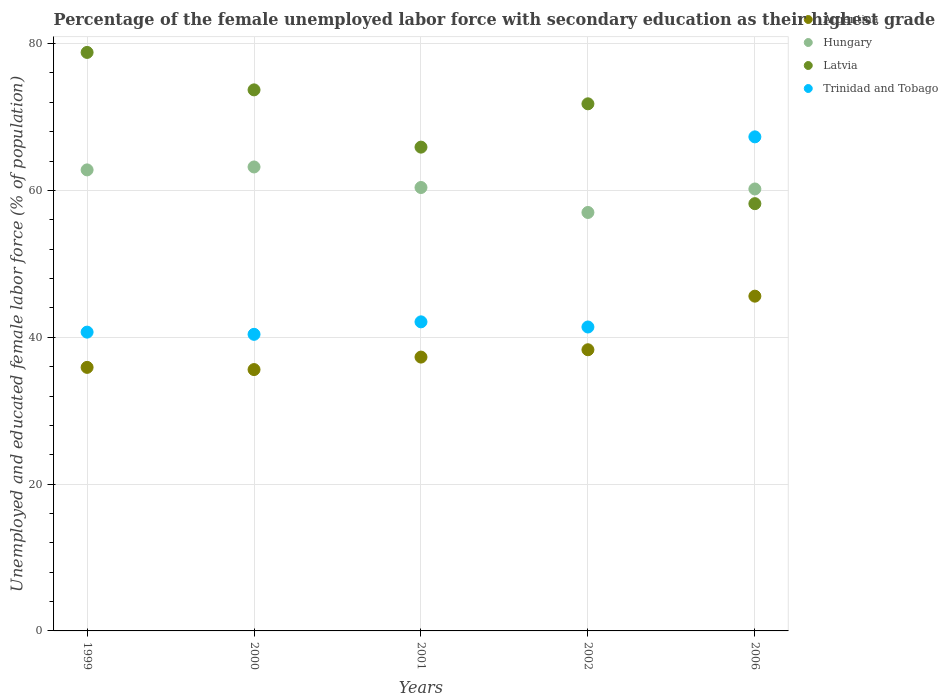How many different coloured dotlines are there?
Give a very brief answer. 4. Is the number of dotlines equal to the number of legend labels?
Offer a very short reply. Yes. What is the percentage of the unemployed female labor force with secondary education in Hungary in 2001?
Make the answer very short. 60.4. Across all years, what is the maximum percentage of the unemployed female labor force with secondary education in Hungary?
Your answer should be very brief. 63.2. Across all years, what is the minimum percentage of the unemployed female labor force with secondary education in Argentina?
Offer a very short reply. 35.6. In which year was the percentage of the unemployed female labor force with secondary education in Hungary maximum?
Provide a short and direct response. 2000. What is the total percentage of the unemployed female labor force with secondary education in Hungary in the graph?
Make the answer very short. 303.6. What is the difference between the percentage of the unemployed female labor force with secondary education in Argentina in 2000 and that in 2002?
Provide a succinct answer. -2.7. What is the difference between the percentage of the unemployed female labor force with secondary education in Latvia in 2006 and the percentage of the unemployed female labor force with secondary education in Trinidad and Tobago in 2001?
Ensure brevity in your answer.  16.1. What is the average percentage of the unemployed female labor force with secondary education in Trinidad and Tobago per year?
Offer a very short reply. 46.38. In the year 2000, what is the difference between the percentage of the unemployed female labor force with secondary education in Trinidad and Tobago and percentage of the unemployed female labor force with secondary education in Hungary?
Offer a very short reply. -22.8. What is the ratio of the percentage of the unemployed female labor force with secondary education in Hungary in 2000 to that in 2002?
Provide a short and direct response. 1.11. Is the percentage of the unemployed female labor force with secondary education in Trinidad and Tobago in 1999 less than that in 2002?
Offer a terse response. Yes. Is the difference between the percentage of the unemployed female labor force with secondary education in Trinidad and Tobago in 1999 and 2006 greater than the difference between the percentage of the unemployed female labor force with secondary education in Hungary in 1999 and 2006?
Make the answer very short. No. What is the difference between the highest and the second highest percentage of the unemployed female labor force with secondary education in Hungary?
Make the answer very short. 0.4. What is the difference between the highest and the lowest percentage of the unemployed female labor force with secondary education in Hungary?
Your answer should be compact. 6.2. Is it the case that in every year, the sum of the percentage of the unemployed female labor force with secondary education in Hungary and percentage of the unemployed female labor force with secondary education in Argentina  is greater than the sum of percentage of the unemployed female labor force with secondary education in Trinidad and Tobago and percentage of the unemployed female labor force with secondary education in Latvia?
Offer a terse response. No. Does the percentage of the unemployed female labor force with secondary education in Hungary monotonically increase over the years?
Make the answer very short. No. How many dotlines are there?
Make the answer very short. 4. What is the difference between two consecutive major ticks on the Y-axis?
Ensure brevity in your answer.  20. Are the values on the major ticks of Y-axis written in scientific E-notation?
Keep it short and to the point. No. Does the graph contain grids?
Ensure brevity in your answer.  Yes. Where does the legend appear in the graph?
Provide a short and direct response. Top right. What is the title of the graph?
Provide a short and direct response. Percentage of the female unemployed labor force with secondary education as their highest grade. What is the label or title of the Y-axis?
Your answer should be compact. Unemployed and educated female labor force (% of population). What is the Unemployed and educated female labor force (% of population) in Argentina in 1999?
Make the answer very short. 35.9. What is the Unemployed and educated female labor force (% of population) in Hungary in 1999?
Provide a succinct answer. 62.8. What is the Unemployed and educated female labor force (% of population) in Latvia in 1999?
Offer a terse response. 78.8. What is the Unemployed and educated female labor force (% of population) of Trinidad and Tobago in 1999?
Ensure brevity in your answer.  40.7. What is the Unemployed and educated female labor force (% of population) of Argentina in 2000?
Your answer should be very brief. 35.6. What is the Unemployed and educated female labor force (% of population) of Hungary in 2000?
Your response must be concise. 63.2. What is the Unemployed and educated female labor force (% of population) in Latvia in 2000?
Offer a very short reply. 73.7. What is the Unemployed and educated female labor force (% of population) of Trinidad and Tobago in 2000?
Provide a succinct answer. 40.4. What is the Unemployed and educated female labor force (% of population) in Argentina in 2001?
Offer a very short reply. 37.3. What is the Unemployed and educated female labor force (% of population) in Hungary in 2001?
Your answer should be compact. 60.4. What is the Unemployed and educated female labor force (% of population) of Latvia in 2001?
Keep it short and to the point. 65.9. What is the Unemployed and educated female labor force (% of population) in Trinidad and Tobago in 2001?
Make the answer very short. 42.1. What is the Unemployed and educated female labor force (% of population) of Argentina in 2002?
Ensure brevity in your answer.  38.3. What is the Unemployed and educated female labor force (% of population) in Latvia in 2002?
Give a very brief answer. 71.8. What is the Unemployed and educated female labor force (% of population) of Trinidad and Tobago in 2002?
Offer a terse response. 41.4. What is the Unemployed and educated female labor force (% of population) in Argentina in 2006?
Give a very brief answer. 45.6. What is the Unemployed and educated female labor force (% of population) in Hungary in 2006?
Keep it short and to the point. 60.2. What is the Unemployed and educated female labor force (% of population) in Latvia in 2006?
Your response must be concise. 58.2. What is the Unemployed and educated female labor force (% of population) of Trinidad and Tobago in 2006?
Keep it short and to the point. 67.3. Across all years, what is the maximum Unemployed and educated female labor force (% of population) in Argentina?
Your response must be concise. 45.6. Across all years, what is the maximum Unemployed and educated female labor force (% of population) in Hungary?
Offer a very short reply. 63.2. Across all years, what is the maximum Unemployed and educated female labor force (% of population) of Latvia?
Offer a terse response. 78.8. Across all years, what is the maximum Unemployed and educated female labor force (% of population) in Trinidad and Tobago?
Provide a succinct answer. 67.3. Across all years, what is the minimum Unemployed and educated female labor force (% of population) in Argentina?
Keep it short and to the point. 35.6. Across all years, what is the minimum Unemployed and educated female labor force (% of population) in Hungary?
Give a very brief answer. 57. Across all years, what is the minimum Unemployed and educated female labor force (% of population) in Latvia?
Your response must be concise. 58.2. Across all years, what is the minimum Unemployed and educated female labor force (% of population) in Trinidad and Tobago?
Provide a short and direct response. 40.4. What is the total Unemployed and educated female labor force (% of population) of Argentina in the graph?
Give a very brief answer. 192.7. What is the total Unemployed and educated female labor force (% of population) in Hungary in the graph?
Ensure brevity in your answer.  303.6. What is the total Unemployed and educated female labor force (% of population) of Latvia in the graph?
Provide a succinct answer. 348.4. What is the total Unemployed and educated female labor force (% of population) of Trinidad and Tobago in the graph?
Provide a succinct answer. 231.9. What is the difference between the Unemployed and educated female labor force (% of population) in Argentina in 1999 and that in 2000?
Provide a succinct answer. 0.3. What is the difference between the Unemployed and educated female labor force (% of population) in Trinidad and Tobago in 1999 and that in 2000?
Your response must be concise. 0.3. What is the difference between the Unemployed and educated female labor force (% of population) in Latvia in 1999 and that in 2001?
Give a very brief answer. 12.9. What is the difference between the Unemployed and educated female labor force (% of population) of Argentina in 1999 and that in 2002?
Your answer should be compact. -2.4. What is the difference between the Unemployed and educated female labor force (% of population) of Hungary in 1999 and that in 2002?
Ensure brevity in your answer.  5.8. What is the difference between the Unemployed and educated female labor force (% of population) in Latvia in 1999 and that in 2002?
Your answer should be very brief. 7. What is the difference between the Unemployed and educated female labor force (% of population) in Argentina in 1999 and that in 2006?
Offer a terse response. -9.7. What is the difference between the Unemployed and educated female labor force (% of population) in Hungary in 1999 and that in 2006?
Give a very brief answer. 2.6. What is the difference between the Unemployed and educated female labor force (% of population) of Latvia in 1999 and that in 2006?
Ensure brevity in your answer.  20.6. What is the difference between the Unemployed and educated female labor force (% of population) of Trinidad and Tobago in 1999 and that in 2006?
Give a very brief answer. -26.6. What is the difference between the Unemployed and educated female labor force (% of population) in Argentina in 2000 and that in 2001?
Keep it short and to the point. -1.7. What is the difference between the Unemployed and educated female labor force (% of population) in Latvia in 2000 and that in 2002?
Keep it short and to the point. 1.9. What is the difference between the Unemployed and educated female labor force (% of population) in Trinidad and Tobago in 2000 and that in 2002?
Your response must be concise. -1. What is the difference between the Unemployed and educated female labor force (% of population) in Trinidad and Tobago in 2000 and that in 2006?
Offer a very short reply. -26.9. What is the difference between the Unemployed and educated female labor force (% of population) of Argentina in 2001 and that in 2002?
Your answer should be compact. -1. What is the difference between the Unemployed and educated female labor force (% of population) of Hungary in 2001 and that in 2002?
Offer a very short reply. 3.4. What is the difference between the Unemployed and educated female labor force (% of population) of Trinidad and Tobago in 2001 and that in 2002?
Make the answer very short. 0.7. What is the difference between the Unemployed and educated female labor force (% of population) of Trinidad and Tobago in 2001 and that in 2006?
Your answer should be very brief. -25.2. What is the difference between the Unemployed and educated female labor force (% of population) of Latvia in 2002 and that in 2006?
Your answer should be compact. 13.6. What is the difference between the Unemployed and educated female labor force (% of population) in Trinidad and Tobago in 2002 and that in 2006?
Provide a succinct answer. -25.9. What is the difference between the Unemployed and educated female labor force (% of population) of Argentina in 1999 and the Unemployed and educated female labor force (% of population) of Hungary in 2000?
Ensure brevity in your answer.  -27.3. What is the difference between the Unemployed and educated female labor force (% of population) in Argentina in 1999 and the Unemployed and educated female labor force (% of population) in Latvia in 2000?
Provide a short and direct response. -37.8. What is the difference between the Unemployed and educated female labor force (% of population) of Hungary in 1999 and the Unemployed and educated female labor force (% of population) of Trinidad and Tobago in 2000?
Offer a very short reply. 22.4. What is the difference between the Unemployed and educated female labor force (% of population) in Latvia in 1999 and the Unemployed and educated female labor force (% of population) in Trinidad and Tobago in 2000?
Give a very brief answer. 38.4. What is the difference between the Unemployed and educated female labor force (% of population) of Argentina in 1999 and the Unemployed and educated female labor force (% of population) of Hungary in 2001?
Give a very brief answer. -24.5. What is the difference between the Unemployed and educated female labor force (% of population) of Argentina in 1999 and the Unemployed and educated female labor force (% of population) of Latvia in 2001?
Make the answer very short. -30. What is the difference between the Unemployed and educated female labor force (% of population) in Argentina in 1999 and the Unemployed and educated female labor force (% of population) in Trinidad and Tobago in 2001?
Your answer should be compact. -6.2. What is the difference between the Unemployed and educated female labor force (% of population) in Hungary in 1999 and the Unemployed and educated female labor force (% of population) in Latvia in 2001?
Make the answer very short. -3.1. What is the difference between the Unemployed and educated female labor force (% of population) in Hungary in 1999 and the Unemployed and educated female labor force (% of population) in Trinidad and Tobago in 2001?
Ensure brevity in your answer.  20.7. What is the difference between the Unemployed and educated female labor force (% of population) in Latvia in 1999 and the Unemployed and educated female labor force (% of population) in Trinidad and Tobago in 2001?
Make the answer very short. 36.7. What is the difference between the Unemployed and educated female labor force (% of population) of Argentina in 1999 and the Unemployed and educated female labor force (% of population) of Hungary in 2002?
Make the answer very short. -21.1. What is the difference between the Unemployed and educated female labor force (% of population) of Argentina in 1999 and the Unemployed and educated female labor force (% of population) of Latvia in 2002?
Give a very brief answer. -35.9. What is the difference between the Unemployed and educated female labor force (% of population) of Hungary in 1999 and the Unemployed and educated female labor force (% of population) of Trinidad and Tobago in 2002?
Your answer should be very brief. 21.4. What is the difference between the Unemployed and educated female labor force (% of population) of Latvia in 1999 and the Unemployed and educated female labor force (% of population) of Trinidad and Tobago in 2002?
Your answer should be very brief. 37.4. What is the difference between the Unemployed and educated female labor force (% of population) in Argentina in 1999 and the Unemployed and educated female labor force (% of population) in Hungary in 2006?
Make the answer very short. -24.3. What is the difference between the Unemployed and educated female labor force (% of population) of Argentina in 1999 and the Unemployed and educated female labor force (% of population) of Latvia in 2006?
Keep it short and to the point. -22.3. What is the difference between the Unemployed and educated female labor force (% of population) of Argentina in 1999 and the Unemployed and educated female labor force (% of population) of Trinidad and Tobago in 2006?
Your answer should be very brief. -31.4. What is the difference between the Unemployed and educated female labor force (% of population) in Hungary in 1999 and the Unemployed and educated female labor force (% of population) in Latvia in 2006?
Provide a short and direct response. 4.6. What is the difference between the Unemployed and educated female labor force (% of population) of Hungary in 1999 and the Unemployed and educated female labor force (% of population) of Trinidad and Tobago in 2006?
Give a very brief answer. -4.5. What is the difference between the Unemployed and educated female labor force (% of population) in Latvia in 1999 and the Unemployed and educated female labor force (% of population) in Trinidad and Tobago in 2006?
Provide a short and direct response. 11.5. What is the difference between the Unemployed and educated female labor force (% of population) of Argentina in 2000 and the Unemployed and educated female labor force (% of population) of Hungary in 2001?
Offer a very short reply. -24.8. What is the difference between the Unemployed and educated female labor force (% of population) in Argentina in 2000 and the Unemployed and educated female labor force (% of population) in Latvia in 2001?
Your answer should be compact. -30.3. What is the difference between the Unemployed and educated female labor force (% of population) in Argentina in 2000 and the Unemployed and educated female labor force (% of population) in Trinidad and Tobago in 2001?
Offer a very short reply. -6.5. What is the difference between the Unemployed and educated female labor force (% of population) in Hungary in 2000 and the Unemployed and educated female labor force (% of population) in Latvia in 2001?
Provide a short and direct response. -2.7. What is the difference between the Unemployed and educated female labor force (% of population) in Hungary in 2000 and the Unemployed and educated female labor force (% of population) in Trinidad and Tobago in 2001?
Give a very brief answer. 21.1. What is the difference between the Unemployed and educated female labor force (% of population) in Latvia in 2000 and the Unemployed and educated female labor force (% of population) in Trinidad and Tobago in 2001?
Your answer should be compact. 31.6. What is the difference between the Unemployed and educated female labor force (% of population) of Argentina in 2000 and the Unemployed and educated female labor force (% of population) of Hungary in 2002?
Offer a terse response. -21.4. What is the difference between the Unemployed and educated female labor force (% of population) in Argentina in 2000 and the Unemployed and educated female labor force (% of population) in Latvia in 2002?
Your answer should be very brief. -36.2. What is the difference between the Unemployed and educated female labor force (% of population) of Hungary in 2000 and the Unemployed and educated female labor force (% of population) of Trinidad and Tobago in 2002?
Offer a terse response. 21.8. What is the difference between the Unemployed and educated female labor force (% of population) of Latvia in 2000 and the Unemployed and educated female labor force (% of population) of Trinidad and Tobago in 2002?
Make the answer very short. 32.3. What is the difference between the Unemployed and educated female labor force (% of population) in Argentina in 2000 and the Unemployed and educated female labor force (% of population) in Hungary in 2006?
Your answer should be very brief. -24.6. What is the difference between the Unemployed and educated female labor force (% of population) of Argentina in 2000 and the Unemployed and educated female labor force (% of population) of Latvia in 2006?
Offer a very short reply. -22.6. What is the difference between the Unemployed and educated female labor force (% of population) of Argentina in 2000 and the Unemployed and educated female labor force (% of population) of Trinidad and Tobago in 2006?
Give a very brief answer. -31.7. What is the difference between the Unemployed and educated female labor force (% of population) in Hungary in 2000 and the Unemployed and educated female labor force (% of population) in Latvia in 2006?
Offer a very short reply. 5. What is the difference between the Unemployed and educated female labor force (% of population) of Hungary in 2000 and the Unemployed and educated female labor force (% of population) of Trinidad and Tobago in 2006?
Provide a succinct answer. -4.1. What is the difference between the Unemployed and educated female labor force (% of population) in Latvia in 2000 and the Unemployed and educated female labor force (% of population) in Trinidad and Tobago in 2006?
Your response must be concise. 6.4. What is the difference between the Unemployed and educated female labor force (% of population) in Argentina in 2001 and the Unemployed and educated female labor force (% of population) in Hungary in 2002?
Your response must be concise. -19.7. What is the difference between the Unemployed and educated female labor force (% of population) of Argentina in 2001 and the Unemployed and educated female labor force (% of population) of Latvia in 2002?
Keep it short and to the point. -34.5. What is the difference between the Unemployed and educated female labor force (% of population) of Hungary in 2001 and the Unemployed and educated female labor force (% of population) of Trinidad and Tobago in 2002?
Offer a terse response. 19. What is the difference between the Unemployed and educated female labor force (% of population) of Latvia in 2001 and the Unemployed and educated female labor force (% of population) of Trinidad and Tobago in 2002?
Offer a very short reply. 24.5. What is the difference between the Unemployed and educated female labor force (% of population) of Argentina in 2001 and the Unemployed and educated female labor force (% of population) of Hungary in 2006?
Make the answer very short. -22.9. What is the difference between the Unemployed and educated female labor force (% of population) in Argentina in 2001 and the Unemployed and educated female labor force (% of population) in Latvia in 2006?
Give a very brief answer. -20.9. What is the difference between the Unemployed and educated female labor force (% of population) of Argentina in 2001 and the Unemployed and educated female labor force (% of population) of Trinidad and Tobago in 2006?
Your response must be concise. -30. What is the difference between the Unemployed and educated female labor force (% of population) of Latvia in 2001 and the Unemployed and educated female labor force (% of population) of Trinidad and Tobago in 2006?
Provide a short and direct response. -1.4. What is the difference between the Unemployed and educated female labor force (% of population) in Argentina in 2002 and the Unemployed and educated female labor force (% of population) in Hungary in 2006?
Your answer should be compact. -21.9. What is the difference between the Unemployed and educated female labor force (% of population) in Argentina in 2002 and the Unemployed and educated female labor force (% of population) in Latvia in 2006?
Keep it short and to the point. -19.9. What is the difference between the Unemployed and educated female labor force (% of population) in Argentina in 2002 and the Unemployed and educated female labor force (% of population) in Trinidad and Tobago in 2006?
Your answer should be very brief. -29. What is the difference between the Unemployed and educated female labor force (% of population) in Hungary in 2002 and the Unemployed and educated female labor force (% of population) in Latvia in 2006?
Ensure brevity in your answer.  -1.2. What is the difference between the Unemployed and educated female labor force (% of population) of Hungary in 2002 and the Unemployed and educated female labor force (% of population) of Trinidad and Tobago in 2006?
Your answer should be very brief. -10.3. What is the average Unemployed and educated female labor force (% of population) of Argentina per year?
Offer a terse response. 38.54. What is the average Unemployed and educated female labor force (% of population) of Hungary per year?
Keep it short and to the point. 60.72. What is the average Unemployed and educated female labor force (% of population) of Latvia per year?
Your response must be concise. 69.68. What is the average Unemployed and educated female labor force (% of population) of Trinidad and Tobago per year?
Keep it short and to the point. 46.38. In the year 1999, what is the difference between the Unemployed and educated female labor force (% of population) of Argentina and Unemployed and educated female labor force (% of population) of Hungary?
Offer a terse response. -26.9. In the year 1999, what is the difference between the Unemployed and educated female labor force (% of population) in Argentina and Unemployed and educated female labor force (% of population) in Latvia?
Your answer should be compact. -42.9. In the year 1999, what is the difference between the Unemployed and educated female labor force (% of population) of Argentina and Unemployed and educated female labor force (% of population) of Trinidad and Tobago?
Your response must be concise. -4.8. In the year 1999, what is the difference between the Unemployed and educated female labor force (% of population) in Hungary and Unemployed and educated female labor force (% of population) in Trinidad and Tobago?
Provide a succinct answer. 22.1. In the year 1999, what is the difference between the Unemployed and educated female labor force (% of population) in Latvia and Unemployed and educated female labor force (% of population) in Trinidad and Tobago?
Make the answer very short. 38.1. In the year 2000, what is the difference between the Unemployed and educated female labor force (% of population) in Argentina and Unemployed and educated female labor force (% of population) in Hungary?
Your answer should be compact. -27.6. In the year 2000, what is the difference between the Unemployed and educated female labor force (% of population) in Argentina and Unemployed and educated female labor force (% of population) in Latvia?
Provide a short and direct response. -38.1. In the year 2000, what is the difference between the Unemployed and educated female labor force (% of population) of Hungary and Unemployed and educated female labor force (% of population) of Trinidad and Tobago?
Provide a succinct answer. 22.8. In the year 2000, what is the difference between the Unemployed and educated female labor force (% of population) of Latvia and Unemployed and educated female labor force (% of population) of Trinidad and Tobago?
Provide a short and direct response. 33.3. In the year 2001, what is the difference between the Unemployed and educated female labor force (% of population) in Argentina and Unemployed and educated female labor force (% of population) in Hungary?
Your answer should be very brief. -23.1. In the year 2001, what is the difference between the Unemployed and educated female labor force (% of population) in Argentina and Unemployed and educated female labor force (% of population) in Latvia?
Offer a terse response. -28.6. In the year 2001, what is the difference between the Unemployed and educated female labor force (% of population) in Hungary and Unemployed and educated female labor force (% of population) in Latvia?
Offer a very short reply. -5.5. In the year 2001, what is the difference between the Unemployed and educated female labor force (% of population) of Latvia and Unemployed and educated female labor force (% of population) of Trinidad and Tobago?
Ensure brevity in your answer.  23.8. In the year 2002, what is the difference between the Unemployed and educated female labor force (% of population) in Argentina and Unemployed and educated female labor force (% of population) in Hungary?
Provide a short and direct response. -18.7. In the year 2002, what is the difference between the Unemployed and educated female labor force (% of population) in Argentina and Unemployed and educated female labor force (% of population) in Latvia?
Ensure brevity in your answer.  -33.5. In the year 2002, what is the difference between the Unemployed and educated female labor force (% of population) in Hungary and Unemployed and educated female labor force (% of population) in Latvia?
Provide a succinct answer. -14.8. In the year 2002, what is the difference between the Unemployed and educated female labor force (% of population) in Latvia and Unemployed and educated female labor force (% of population) in Trinidad and Tobago?
Ensure brevity in your answer.  30.4. In the year 2006, what is the difference between the Unemployed and educated female labor force (% of population) of Argentina and Unemployed and educated female labor force (% of population) of Hungary?
Your answer should be compact. -14.6. In the year 2006, what is the difference between the Unemployed and educated female labor force (% of population) of Argentina and Unemployed and educated female labor force (% of population) of Latvia?
Your response must be concise. -12.6. In the year 2006, what is the difference between the Unemployed and educated female labor force (% of population) of Argentina and Unemployed and educated female labor force (% of population) of Trinidad and Tobago?
Your response must be concise. -21.7. In the year 2006, what is the difference between the Unemployed and educated female labor force (% of population) in Hungary and Unemployed and educated female labor force (% of population) in Latvia?
Your response must be concise. 2. In the year 2006, what is the difference between the Unemployed and educated female labor force (% of population) in Hungary and Unemployed and educated female labor force (% of population) in Trinidad and Tobago?
Offer a terse response. -7.1. In the year 2006, what is the difference between the Unemployed and educated female labor force (% of population) in Latvia and Unemployed and educated female labor force (% of population) in Trinidad and Tobago?
Provide a succinct answer. -9.1. What is the ratio of the Unemployed and educated female labor force (% of population) of Argentina in 1999 to that in 2000?
Ensure brevity in your answer.  1.01. What is the ratio of the Unemployed and educated female labor force (% of population) in Latvia in 1999 to that in 2000?
Your response must be concise. 1.07. What is the ratio of the Unemployed and educated female labor force (% of population) of Trinidad and Tobago in 1999 to that in 2000?
Your answer should be very brief. 1.01. What is the ratio of the Unemployed and educated female labor force (% of population) in Argentina in 1999 to that in 2001?
Your response must be concise. 0.96. What is the ratio of the Unemployed and educated female labor force (% of population) of Hungary in 1999 to that in 2001?
Ensure brevity in your answer.  1.04. What is the ratio of the Unemployed and educated female labor force (% of population) in Latvia in 1999 to that in 2001?
Provide a succinct answer. 1.2. What is the ratio of the Unemployed and educated female labor force (% of population) of Trinidad and Tobago in 1999 to that in 2001?
Your response must be concise. 0.97. What is the ratio of the Unemployed and educated female labor force (% of population) in Argentina in 1999 to that in 2002?
Provide a succinct answer. 0.94. What is the ratio of the Unemployed and educated female labor force (% of population) in Hungary in 1999 to that in 2002?
Ensure brevity in your answer.  1.1. What is the ratio of the Unemployed and educated female labor force (% of population) of Latvia in 1999 to that in 2002?
Make the answer very short. 1.1. What is the ratio of the Unemployed and educated female labor force (% of population) of Trinidad and Tobago in 1999 to that in 2002?
Offer a terse response. 0.98. What is the ratio of the Unemployed and educated female labor force (% of population) of Argentina in 1999 to that in 2006?
Your answer should be very brief. 0.79. What is the ratio of the Unemployed and educated female labor force (% of population) of Hungary in 1999 to that in 2006?
Your answer should be very brief. 1.04. What is the ratio of the Unemployed and educated female labor force (% of population) of Latvia in 1999 to that in 2006?
Offer a very short reply. 1.35. What is the ratio of the Unemployed and educated female labor force (% of population) in Trinidad and Tobago in 1999 to that in 2006?
Your answer should be very brief. 0.6. What is the ratio of the Unemployed and educated female labor force (% of population) in Argentina in 2000 to that in 2001?
Offer a terse response. 0.95. What is the ratio of the Unemployed and educated female labor force (% of population) in Hungary in 2000 to that in 2001?
Give a very brief answer. 1.05. What is the ratio of the Unemployed and educated female labor force (% of population) of Latvia in 2000 to that in 2001?
Your answer should be very brief. 1.12. What is the ratio of the Unemployed and educated female labor force (% of population) of Trinidad and Tobago in 2000 to that in 2001?
Ensure brevity in your answer.  0.96. What is the ratio of the Unemployed and educated female labor force (% of population) of Argentina in 2000 to that in 2002?
Make the answer very short. 0.93. What is the ratio of the Unemployed and educated female labor force (% of population) of Hungary in 2000 to that in 2002?
Offer a very short reply. 1.11. What is the ratio of the Unemployed and educated female labor force (% of population) in Latvia in 2000 to that in 2002?
Offer a terse response. 1.03. What is the ratio of the Unemployed and educated female labor force (% of population) of Trinidad and Tobago in 2000 to that in 2002?
Offer a very short reply. 0.98. What is the ratio of the Unemployed and educated female labor force (% of population) in Argentina in 2000 to that in 2006?
Keep it short and to the point. 0.78. What is the ratio of the Unemployed and educated female labor force (% of population) in Hungary in 2000 to that in 2006?
Offer a terse response. 1.05. What is the ratio of the Unemployed and educated female labor force (% of population) in Latvia in 2000 to that in 2006?
Keep it short and to the point. 1.27. What is the ratio of the Unemployed and educated female labor force (% of population) of Trinidad and Tobago in 2000 to that in 2006?
Your response must be concise. 0.6. What is the ratio of the Unemployed and educated female labor force (% of population) of Argentina in 2001 to that in 2002?
Your response must be concise. 0.97. What is the ratio of the Unemployed and educated female labor force (% of population) in Hungary in 2001 to that in 2002?
Offer a terse response. 1.06. What is the ratio of the Unemployed and educated female labor force (% of population) of Latvia in 2001 to that in 2002?
Give a very brief answer. 0.92. What is the ratio of the Unemployed and educated female labor force (% of population) in Trinidad and Tobago in 2001 to that in 2002?
Your response must be concise. 1.02. What is the ratio of the Unemployed and educated female labor force (% of population) of Argentina in 2001 to that in 2006?
Ensure brevity in your answer.  0.82. What is the ratio of the Unemployed and educated female labor force (% of population) of Hungary in 2001 to that in 2006?
Your answer should be compact. 1. What is the ratio of the Unemployed and educated female labor force (% of population) in Latvia in 2001 to that in 2006?
Make the answer very short. 1.13. What is the ratio of the Unemployed and educated female labor force (% of population) in Trinidad and Tobago in 2001 to that in 2006?
Ensure brevity in your answer.  0.63. What is the ratio of the Unemployed and educated female labor force (% of population) of Argentina in 2002 to that in 2006?
Provide a short and direct response. 0.84. What is the ratio of the Unemployed and educated female labor force (% of population) of Hungary in 2002 to that in 2006?
Give a very brief answer. 0.95. What is the ratio of the Unemployed and educated female labor force (% of population) of Latvia in 2002 to that in 2006?
Make the answer very short. 1.23. What is the ratio of the Unemployed and educated female labor force (% of population) of Trinidad and Tobago in 2002 to that in 2006?
Make the answer very short. 0.62. What is the difference between the highest and the second highest Unemployed and educated female labor force (% of population) of Hungary?
Offer a very short reply. 0.4. What is the difference between the highest and the second highest Unemployed and educated female labor force (% of population) of Latvia?
Give a very brief answer. 5.1. What is the difference between the highest and the second highest Unemployed and educated female labor force (% of population) in Trinidad and Tobago?
Ensure brevity in your answer.  25.2. What is the difference between the highest and the lowest Unemployed and educated female labor force (% of population) in Latvia?
Make the answer very short. 20.6. What is the difference between the highest and the lowest Unemployed and educated female labor force (% of population) in Trinidad and Tobago?
Make the answer very short. 26.9. 